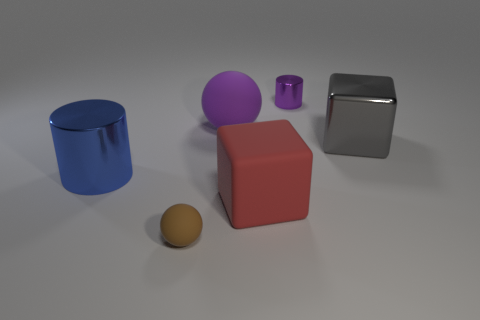The big thing that is both in front of the big shiny cube and behind the large red object is made of what material?
Give a very brief answer. Metal. How many objects are either small things in front of the large gray shiny object or large red blocks?
Ensure brevity in your answer.  2. Is the color of the metallic block the same as the tiny rubber object?
Your answer should be very brief. No. Is there a purple block that has the same size as the purple cylinder?
Keep it short and to the point. No. What number of shiny cylinders are both on the right side of the big blue cylinder and on the left side of the small metal object?
Your answer should be very brief. 0. How many large blue cylinders are behind the purple cylinder?
Offer a very short reply. 0. Are there any tiny purple matte objects that have the same shape as the big blue thing?
Provide a short and direct response. No. Does the large blue shiny object have the same shape as the rubber thing to the left of the large sphere?
Keep it short and to the point. No. How many balls are either tiny shiny objects or gray things?
Your answer should be compact. 0. What is the shape of the large object that is left of the small rubber object?
Make the answer very short. Cylinder. 